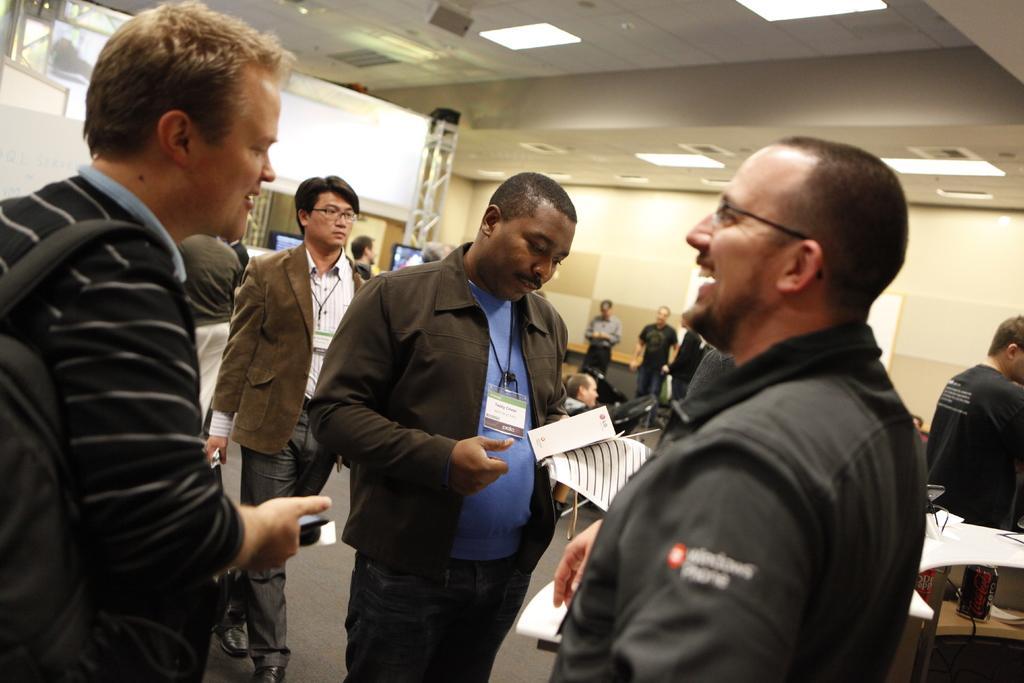Could you give a brief overview of what you see in this image? In this image there is a person holding the papers. Before him there is a person wearing spectacles. Left side there is a person carrying a bag and he is holding an object. There are people on the floor. Few people are sitting on the chairs. Right side there is a table having few objects. Middle of the image there are screens behind the people. Top of the image there are lights attached to the roof. 